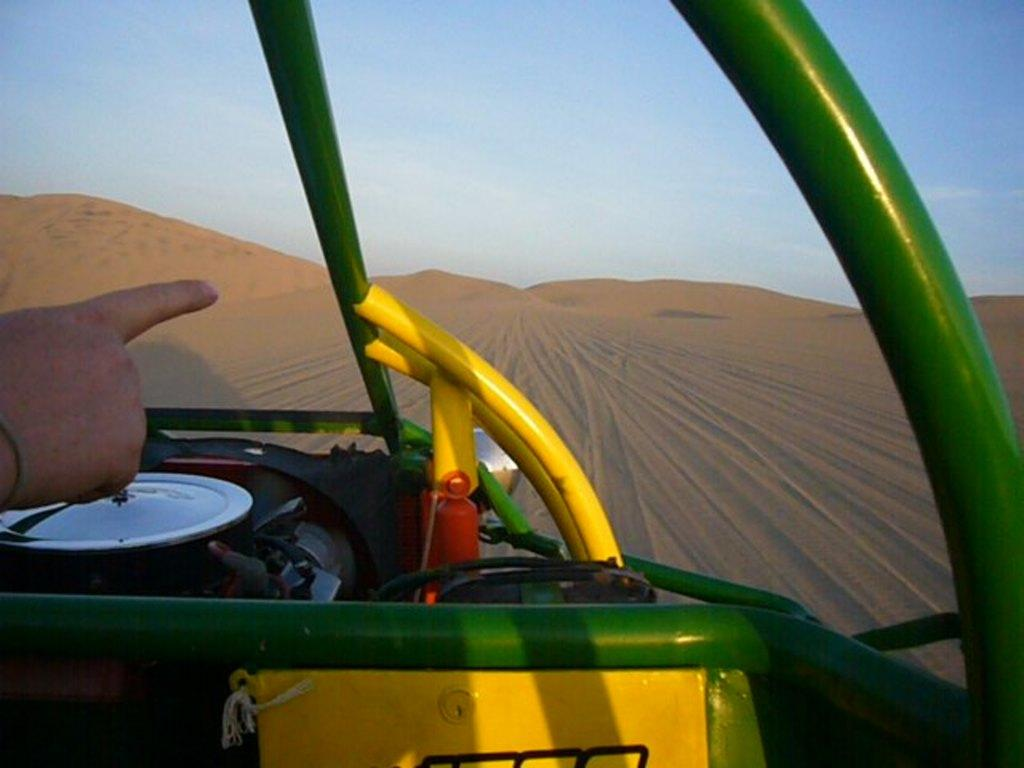What can be seen on the left side of the image? There is a person's hand on the left side of the image. What is located at the bottom of the image? There is a vehicle at the bottom of the image. What type of terrain is visible in the background of the image? There is sand visible in the background of the image. What is visible at the top of the image? The sky is visible at the top of the image. What year is depicted in the image? The image does not depict a specific year; it is a photograph or illustration of a scene. Can you see any footprints in the sand in the image? There is no mention of footprints in the sand in the provided facts, so we cannot determine if they are present in the image. 